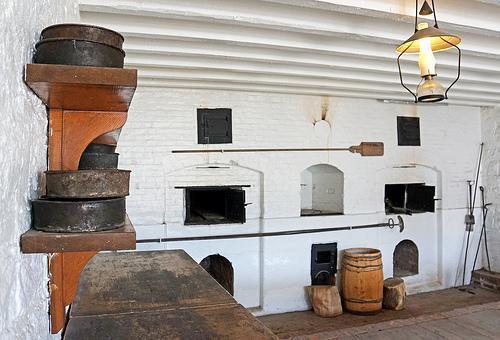How many lights are there?
Give a very brief answer. 1. 